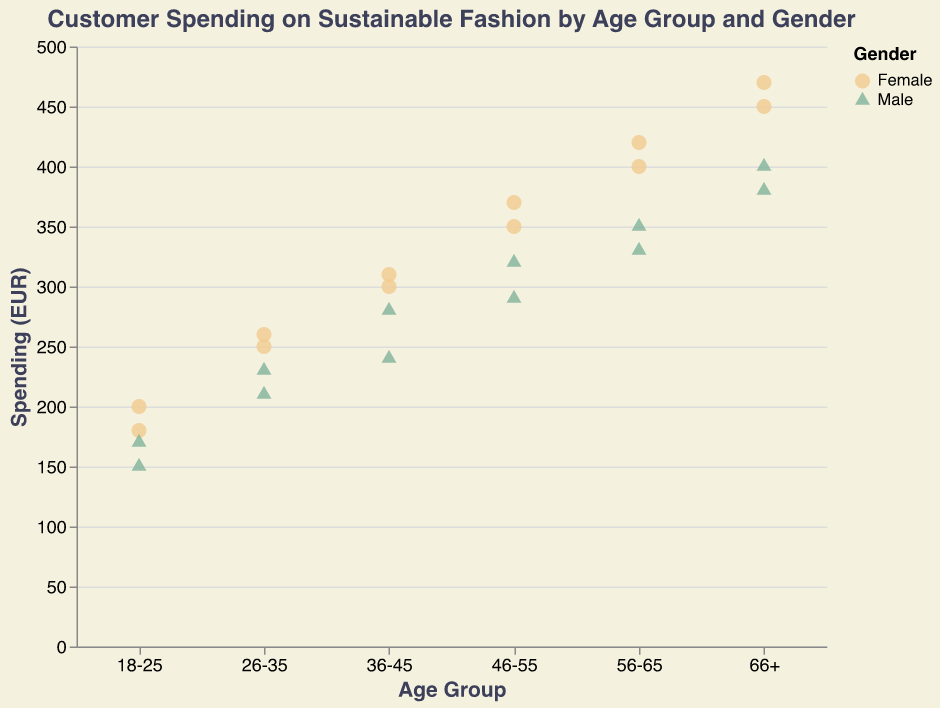What is the title of the scatter plot? The title is usually displayed at the top of the chart. In this case, it is "Customer Spending on Sustainable Fashion by Age Group and Gender."
Answer: Customer Spending on Sustainable Fashion by Age Group and Gender How many data points are there for the "18-25" age group? According to the scatter plot, there are 4 data points in the "18-25" age group, divided between male and female genders.
Answer: 4 Which age group has the highest spending by an individual? The highest individual spending is visible on the y-axis scale. It is 470 EUR by Ruth Ludwig in the "66+" age group.
Answer: 66+ What is the average spending for males in the "26-35" age group? The data points for males in the "26-35" age group are 230 and 210 EUR. The average spending is calculated as (230+210)/2 = 220 EUR.
Answer: 220 Is there a gender difference in spending for the "56-65" age group? By comparing the data points for the "56-65" age group, females have spending values of 400 and 420 EUR, and males have spending values of 350 and 330 EUR. The lowest value for females is higher than the highest value for males.
Answer: Yes Which gender generally spends more in the "46-55" age group? By comparing the data points, females have spending values of 350 and 370 EUR, whereas males have spending values of 320 and 290 EUR. Females generally spend more.
Answer: Females Is there a trend of increasing spending with higher age groups for females? By observing the scatter plot, we see that the spending amounts for females increase across the age groups from "18-25" (200, 180) to "66+" (450, 470).
Answer: Yes How does the spending behavior of the "36-45" age group differ between males and females? In the "36-45" age group, females have spending values of 300 and 310 EUR, whereas males have spending values of 280 and 240 EUR. Females spend more on average.
Answer: Females spend more What is the gender with the least variability in spending in the "18-25" age group? For "18-25" age group, males have spending of 150 and 170 EUR, while females have 200 and 180 EUR. The variability (range) is smaller for males (170-150=20) compared to females (200-180=20).
Answer: Males 